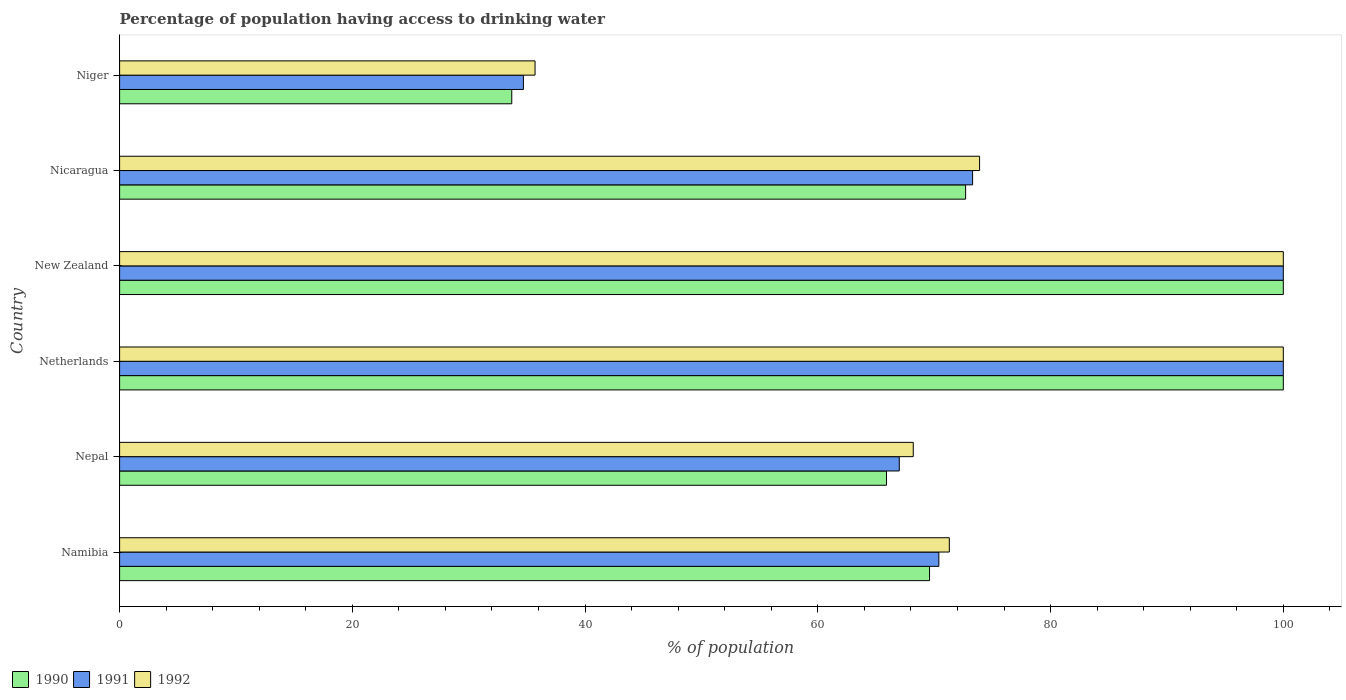How many groups of bars are there?
Offer a very short reply. 6. Are the number of bars per tick equal to the number of legend labels?
Offer a very short reply. Yes. Are the number of bars on each tick of the Y-axis equal?
Give a very brief answer. Yes. How many bars are there on the 5th tick from the top?
Keep it short and to the point. 3. What is the label of the 5th group of bars from the top?
Offer a terse response. Nepal. Across all countries, what is the maximum percentage of population having access to drinking water in 1991?
Keep it short and to the point. 100. Across all countries, what is the minimum percentage of population having access to drinking water in 1991?
Keep it short and to the point. 34.7. In which country was the percentage of population having access to drinking water in 1992 minimum?
Keep it short and to the point. Niger. What is the total percentage of population having access to drinking water in 1991 in the graph?
Provide a short and direct response. 445.4. What is the difference between the percentage of population having access to drinking water in 1990 in Nepal and that in Netherlands?
Make the answer very short. -34.1. What is the difference between the percentage of population having access to drinking water in 1992 in Netherlands and the percentage of population having access to drinking water in 1991 in Nepal?
Ensure brevity in your answer.  33. What is the average percentage of population having access to drinking water in 1992 per country?
Offer a terse response. 74.85. What is the ratio of the percentage of population having access to drinking water in 1991 in Netherlands to that in Nicaragua?
Ensure brevity in your answer.  1.36. Is the difference between the percentage of population having access to drinking water in 1992 in Namibia and New Zealand greater than the difference between the percentage of population having access to drinking water in 1990 in Namibia and New Zealand?
Give a very brief answer. Yes. What is the difference between the highest and the lowest percentage of population having access to drinking water in 1991?
Ensure brevity in your answer.  65.3. Is the sum of the percentage of population having access to drinking water in 1992 in Nepal and Niger greater than the maximum percentage of population having access to drinking water in 1991 across all countries?
Keep it short and to the point. Yes. What does the 1st bar from the top in Nicaragua represents?
Ensure brevity in your answer.  1992. Is it the case that in every country, the sum of the percentage of population having access to drinking water in 1991 and percentage of population having access to drinking water in 1992 is greater than the percentage of population having access to drinking water in 1990?
Make the answer very short. Yes. Does the graph contain any zero values?
Give a very brief answer. No. Where does the legend appear in the graph?
Keep it short and to the point. Bottom left. How many legend labels are there?
Give a very brief answer. 3. How are the legend labels stacked?
Offer a very short reply. Horizontal. What is the title of the graph?
Give a very brief answer. Percentage of population having access to drinking water. What is the label or title of the X-axis?
Keep it short and to the point. % of population. What is the label or title of the Y-axis?
Your answer should be very brief. Country. What is the % of population in 1990 in Namibia?
Make the answer very short. 69.6. What is the % of population of 1991 in Namibia?
Ensure brevity in your answer.  70.4. What is the % of population of 1992 in Namibia?
Make the answer very short. 71.3. What is the % of population in 1990 in Nepal?
Your answer should be very brief. 65.9. What is the % of population in 1992 in Nepal?
Your answer should be compact. 68.2. What is the % of population in 1991 in Netherlands?
Make the answer very short. 100. What is the % of population in 1991 in New Zealand?
Offer a very short reply. 100. What is the % of population in 1992 in New Zealand?
Give a very brief answer. 100. What is the % of population in 1990 in Nicaragua?
Ensure brevity in your answer.  72.7. What is the % of population in 1991 in Nicaragua?
Give a very brief answer. 73.3. What is the % of population of 1992 in Nicaragua?
Offer a very short reply. 73.9. What is the % of population of 1990 in Niger?
Provide a succinct answer. 33.7. What is the % of population of 1991 in Niger?
Your answer should be very brief. 34.7. What is the % of population in 1992 in Niger?
Your answer should be compact. 35.7. Across all countries, what is the maximum % of population in 1991?
Ensure brevity in your answer.  100. Across all countries, what is the minimum % of population in 1990?
Give a very brief answer. 33.7. Across all countries, what is the minimum % of population of 1991?
Ensure brevity in your answer.  34.7. Across all countries, what is the minimum % of population of 1992?
Your answer should be very brief. 35.7. What is the total % of population of 1990 in the graph?
Your answer should be compact. 441.9. What is the total % of population of 1991 in the graph?
Your answer should be very brief. 445.4. What is the total % of population of 1992 in the graph?
Offer a very short reply. 449.1. What is the difference between the % of population in 1991 in Namibia and that in Nepal?
Provide a short and direct response. 3.4. What is the difference between the % of population in 1990 in Namibia and that in Netherlands?
Your answer should be very brief. -30.4. What is the difference between the % of population in 1991 in Namibia and that in Netherlands?
Offer a terse response. -29.6. What is the difference between the % of population of 1992 in Namibia and that in Netherlands?
Your answer should be compact. -28.7. What is the difference between the % of population of 1990 in Namibia and that in New Zealand?
Ensure brevity in your answer.  -30.4. What is the difference between the % of population of 1991 in Namibia and that in New Zealand?
Keep it short and to the point. -29.6. What is the difference between the % of population in 1992 in Namibia and that in New Zealand?
Make the answer very short. -28.7. What is the difference between the % of population in 1990 in Namibia and that in Nicaragua?
Offer a very short reply. -3.1. What is the difference between the % of population in 1990 in Namibia and that in Niger?
Offer a terse response. 35.9. What is the difference between the % of population of 1991 in Namibia and that in Niger?
Provide a short and direct response. 35.7. What is the difference between the % of population of 1992 in Namibia and that in Niger?
Offer a terse response. 35.6. What is the difference between the % of population of 1990 in Nepal and that in Netherlands?
Make the answer very short. -34.1. What is the difference between the % of population of 1991 in Nepal and that in Netherlands?
Your response must be concise. -33. What is the difference between the % of population in 1992 in Nepal and that in Netherlands?
Offer a very short reply. -31.8. What is the difference between the % of population in 1990 in Nepal and that in New Zealand?
Provide a succinct answer. -34.1. What is the difference between the % of population of 1991 in Nepal and that in New Zealand?
Your answer should be very brief. -33. What is the difference between the % of population in 1992 in Nepal and that in New Zealand?
Offer a terse response. -31.8. What is the difference between the % of population in 1991 in Nepal and that in Nicaragua?
Your answer should be compact. -6.3. What is the difference between the % of population of 1992 in Nepal and that in Nicaragua?
Provide a succinct answer. -5.7. What is the difference between the % of population in 1990 in Nepal and that in Niger?
Your answer should be very brief. 32.2. What is the difference between the % of population in 1991 in Nepal and that in Niger?
Ensure brevity in your answer.  32.3. What is the difference between the % of population of 1992 in Nepal and that in Niger?
Your answer should be compact. 32.5. What is the difference between the % of population in 1990 in Netherlands and that in New Zealand?
Ensure brevity in your answer.  0. What is the difference between the % of population of 1991 in Netherlands and that in New Zealand?
Provide a succinct answer. 0. What is the difference between the % of population in 1992 in Netherlands and that in New Zealand?
Your answer should be very brief. 0. What is the difference between the % of population of 1990 in Netherlands and that in Nicaragua?
Keep it short and to the point. 27.3. What is the difference between the % of population in 1991 in Netherlands and that in Nicaragua?
Offer a very short reply. 26.7. What is the difference between the % of population of 1992 in Netherlands and that in Nicaragua?
Provide a short and direct response. 26.1. What is the difference between the % of population of 1990 in Netherlands and that in Niger?
Provide a short and direct response. 66.3. What is the difference between the % of population of 1991 in Netherlands and that in Niger?
Offer a very short reply. 65.3. What is the difference between the % of population of 1992 in Netherlands and that in Niger?
Your response must be concise. 64.3. What is the difference between the % of population of 1990 in New Zealand and that in Nicaragua?
Offer a terse response. 27.3. What is the difference between the % of population of 1991 in New Zealand and that in Nicaragua?
Offer a very short reply. 26.7. What is the difference between the % of population of 1992 in New Zealand and that in Nicaragua?
Make the answer very short. 26.1. What is the difference between the % of population in 1990 in New Zealand and that in Niger?
Your answer should be very brief. 66.3. What is the difference between the % of population of 1991 in New Zealand and that in Niger?
Your answer should be very brief. 65.3. What is the difference between the % of population of 1992 in New Zealand and that in Niger?
Your response must be concise. 64.3. What is the difference between the % of population in 1990 in Nicaragua and that in Niger?
Your answer should be compact. 39. What is the difference between the % of population of 1991 in Nicaragua and that in Niger?
Offer a terse response. 38.6. What is the difference between the % of population in 1992 in Nicaragua and that in Niger?
Your answer should be compact. 38.2. What is the difference between the % of population in 1990 in Namibia and the % of population in 1991 in Nepal?
Your response must be concise. 2.6. What is the difference between the % of population of 1990 in Namibia and the % of population of 1992 in Nepal?
Give a very brief answer. 1.4. What is the difference between the % of population in 1991 in Namibia and the % of population in 1992 in Nepal?
Make the answer very short. 2.2. What is the difference between the % of population of 1990 in Namibia and the % of population of 1991 in Netherlands?
Keep it short and to the point. -30.4. What is the difference between the % of population in 1990 in Namibia and the % of population in 1992 in Netherlands?
Make the answer very short. -30.4. What is the difference between the % of population in 1991 in Namibia and the % of population in 1992 in Netherlands?
Your answer should be compact. -29.6. What is the difference between the % of population of 1990 in Namibia and the % of population of 1991 in New Zealand?
Your answer should be very brief. -30.4. What is the difference between the % of population in 1990 in Namibia and the % of population in 1992 in New Zealand?
Ensure brevity in your answer.  -30.4. What is the difference between the % of population in 1991 in Namibia and the % of population in 1992 in New Zealand?
Provide a succinct answer. -29.6. What is the difference between the % of population of 1990 in Namibia and the % of population of 1991 in Nicaragua?
Ensure brevity in your answer.  -3.7. What is the difference between the % of population of 1990 in Namibia and the % of population of 1991 in Niger?
Your answer should be compact. 34.9. What is the difference between the % of population in 1990 in Namibia and the % of population in 1992 in Niger?
Provide a succinct answer. 33.9. What is the difference between the % of population of 1991 in Namibia and the % of population of 1992 in Niger?
Ensure brevity in your answer.  34.7. What is the difference between the % of population of 1990 in Nepal and the % of population of 1991 in Netherlands?
Ensure brevity in your answer.  -34.1. What is the difference between the % of population of 1990 in Nepal and the % of population of 1992 in Netherlands?
Ensure brevity in your answer.  -34.1. What is the difference between the % of population of 1991 in Nepal and the % of population of 1992 in Netherlands?
Make the answer very short. -33. What is the difference between the % of population of 1990 in Nepal and the % of population of 1991 in New Zealand?
Provide a succinct answer. -34.1. What is the difference between the % of population of 1990 in Nepal and the % of population of 1992 in New Zealand?
Your answer should be very brief. -34.1. What is the difference between the % of population in 1991 in Nepal and the % of population in 1992 in New Zealand?
Your response must be concise. -33. What is the difference between the % of population in 1990 in Nepal and the % of population in 1991 in Nicaragua?
Your answer should be very brief. -7.4. What is the difference between the % of population in 1990 in Nepal and the % of population in 1991 in Niger?
Keep it short and to the point. 31.2. What is the difference between the % of population of 1990 in Nepal and the % of population of 1992 in Niger?
Provide a short and direct response. 30.2. What is the difference between the % of population in 1991 in Nepal and the % of population in 1992 in Niger?
Keep it short and to the point. 31.3. What is the difference between the % of population of 1990 in Netherlands and the % of population of 1991 in New Zealand?
Your response must be concise. 0. What is the difference between the % of population in 1990 in Netherlands and the % of population in 1992 in New Zealand?
Give a very brief answer. 0. What is the difference between the % of population in 1991 in Netherlands and the % of population in 1992 in New Zealand?
Provide a short and direct response. 0. What is the difference between the % of population of 1990 in Netherlands and the % of population of 1991 in Nicaragua?
Provide a short and direct response. 26.7. What is the difference between the % of population in 1990 in Netherlands and the % of population in 1992 in Nicaragua?
Keep it short and to the point. 26.1. What is the difference between the % of population of 1991 in Netherlands and the % of population of 1992 in Nicaragua?
Ensure brevity in your answer.  26.1. What is the difference between the % of population in 1990 in Netherlands and the % of population in 1991 in Niger?
Your answer should be very brief. 65.3. What is the difference between the % of population in 1990 in Netherlands and the % of population in 1992 in Niger?
Keep it short and to the point. 64.3. What is the difference between the % of population of 1991 in Netherlands and the % of population of 1992 in Niger?
Provide a succinct answer. 64.3. What is the difference between the % of population in 1990 in New Zealand and the % of population in 1991 in Nicaragua?
Give a very brief answer. 26.7. What is the difference between the % of population in 1990 in New Zealand and the % of population in 1992 in Nicaragua?
Your answer should be very brief. 26.1. What is the difference between the % of population of 1991 in New Zealand and the % of population of 1992 in Nicaragua?
Provide a succinct answer. 26.1. What is the difference between the % of population in 1990 in New Zealand and the % of population in 1991 in Niger?
Ensure brevity in your answer.  65.3. What is the difference between the % of population in 1990 in New Zealand and the % of population in 1992 in Niger?
Offer a very short reply. 64.3. What is the difference between the % of population of 1991 in New Zealand and the % of population of 1992 in Niger?
Offer a very short reply. 64.3. What is the difference between the % of population of 1990 in Nicaragua and the % of population of 1991 in Niger?
Make the answer very short. 38. What is the difference between the % of population of 1990 in Nicaragua and the % of population of 1992 in Niger?
Your answer should be compact. 37. What is the difference between the % of population in 1991 in Nicaragua and the % of population in 1992 in Niger?
Your answer should be very brief. 37.6. What is the average % of population in 1990 per country?
Offer a very short reply. 73.65. What is the average % of population in 1991 per country?
Keep it short and to the point. 74.23. What is the average % of population in 1992 per country?
Keep it short and to the point. 74.85. What is the difference between the % of population of 1990 and % of population of 1992 in Namibia?
Keep it short and to the point. -1.7. What is the difference between the % of population of 1990 and % of population of 1991 in Nepal?
Offer a very short reply. -1.1. What is the difference between the % of population of 1990 and % of population of 1992 in Nepal?
Make the answer very short. -2.3. What is the difference between the % of population in 1991 and % of population in 1992 in Nepal?
Offer a terse response. -1.2. What is the difference between the % of population in 1990 and % of population in 1991 in Netherlands?
Keep it short and to the point. 0. What is the difference between the % of population of 1990 and % of population of 1992 in Netherlands?
Your answer should be very brief. 0. What is the difference between the % of population in 1991 and % of population in 1992 in New Zealand?
Your answer should be very brief. 0. What is the difference between the % of population in 1990 and % of population in 1991 in Nicaragua?
Keep it short and to the point. -0.6. What is the ratio of the % of population in 1990 in Namibia to that in Nepal?
Give a very brief answer. 1.06. What is the ratio of the % of population of 1991 in Namibia to that in Nepal?
Provide a succinct answer. 1.05. What is the ratio of the % of population in 1992 in Namibia to that in Nepal?
Make the answer very short. 1.05. What is the ratio of the % of population in 1990 in Namibia to that in Netherlands?
Your response must be concise. 0.7. What is the ratio of the % of population in 1991 in Namibia to that in Netherlands?
Provide a short and direct response. 0.7. What is the ratio of the % of population of 1992 in Namibia to that in Netherlands?
Make the answer very short. 0.71. What is the ratio of the % of population in 1990 in Namibia to that in New Zealand?
Make the answer very short. 0.7. What is the ratio of the % of population in 1991 in Namibia to that in New Zealand?
Keep it short and to the point. 0.7. What is the ratio of the % of population of 1992 in Namibia to that in New Zealand?
Provide a short and direct response. 0.71. What is the ratio of the % of population in 1990 in Namibia to that in Nicaragua?
Ensure brevity in your answer.  0.96. What is the ratio of the % of population of 1991 in Namibia to that in Nicaragua?
Your response must be concise. 0.96. What is the ratio of the % of population of 1992 in Namibia to that in Nicaragua?
Make the answer very short. 0.96. What is the ratio of the % of population in 1990 in Namibia to that in Niger?
Offer a terse response. 2.07. What is the ratio of the % of population of 1991 in Namibia to that in Niger?
Ensure brevity in your answer.  2.03. What is the ratio of the % of population of 1992 in Namibia to that in Niger?
Make the answer very short. 2. What is the ratio of the % of population in 1990 in Nepal to that in Netherlands?
Make the answer very short. 0.66. What is the ratio of the % of population of 1991 in Nepal to that in Netherlands?
Offer a terse response. 0.67. What is the ratio of the % of population of 1992 in Nepal to that in Netherlands?
Your answer should be very brief. 0.68. What is the ratio of the % of population of 1990 in Nepal to that in New Zealand?
Ensure brevity in your answer.  0.66. What is the ratio of the % of population of 1991 in Nepal to that in New Zealand?
Your answer should be very brief. 0.67. What is the ratio of the % of population in 1992 in Nepal to that in New Zealand?
Offer a very short reply. 0.68. What is the ratio of the % of population of 1990 in Nepal to that in Nicaragua?
Offer a terse response. 0.91. What is the ratio of the % of population in 1991 in Nepal to that in Nicaragua?
Ensure brevity in your answer.  0.91. What is the ratio of the % of population of 1992 in Nepal to that in Nicaragua?
Provide a succinct answer. 0.92. What is the ratio of the % of population in 1990 in Nepal to that in Niger?
Keep it short and to the point. 1.96. What is the ratio of the % of population in 1991 in Nepal to that in Niger?
Provide a succinct answer. 1.93. What is the ratio of the % of population in 1992 in Nepal to that in Niger?
Ensure brevity in your answer.  1.91. What is the ratio of the % of population of 1990 in Netherlands to that in New Zealand?
Make the answer very short. 1. What is the ratio of the % of population of 1990 in Netherlands to that in Nicaragua?
Give a very brief answer. 1.38. What is the ratio of the % of population in 1991 in Netherlands to that in Nicaragua?
Your answer should be compact. 1.36. What is the ratio of the % of population in 1992 in Netherlands to that in Nicaragua?
Give a very brief answer. 1.35. What is the ratio of the % of population of 1990 in Netherlands to that in Niger?
Your answer should be compact. 2.97. What is the ratio of the % of population in 1991 in Netherlands to that in Niger?
Provide a short and direct response. 2.88. What is the ratio of the % of population of 1992 in Netherlands to that in Niger?
Offer a very short reply. 2.8. What is the ratio of the % of population of 1990 in New Zealand to that in Nicaragua?
Provide a short and direct response. 1.38. What is the ratio of the % of population in 1991 in New Zealand to that in Nicaragua?
Your response must be concise. 1.36. What is the ratio of the % of population of 1992 in New Zealand to that in Nicaragua?
Your response must be concise. 1.35. What is the ratio of the % of population in 1990 in New Zealand to that in Niger?
Offer a terse response. 2.97. What is the ratio of the % of population in 1991 in New Zealand to that in Niger?
Your response must be concise. 2.88. What is the ratio of the % of population of 1992 in New Zealand to that in Niger?
Provide a succinct answer. 2.8. What is the ratio of the % of population of 1990 in Nicaragua to that in Niger?
Your answer should be very brief. 2.16. What is the ratio of the % of population in 1991 in Nicaragua to that in Niger?
Your answer should be compact. 2.11. What is the ratio of the % of population in 1992 in Nicaragua to that in Niger?
Ensure brevity in your answer.  2.07. What is the difference between the highest and the second highest % of population of 1990?
Provide a succinct answer. 0. What is the difference between the highest and the second highest % of population in 1991?
Provide a short and direct response. 0. What is the difference between the highest and the second highest % of population in 1992?
Offer a terse response. 0. What is the difference between the highest and the lowest % of population in 1990?
Your answer should be compact. 66.3. What is the difference between the highest and the lowest % of population in 1991?
Provide a succinct answer. 65.3. What is the difference between the highest and the lowest % of population of 1992?
Offer a terse response. 64.3. 